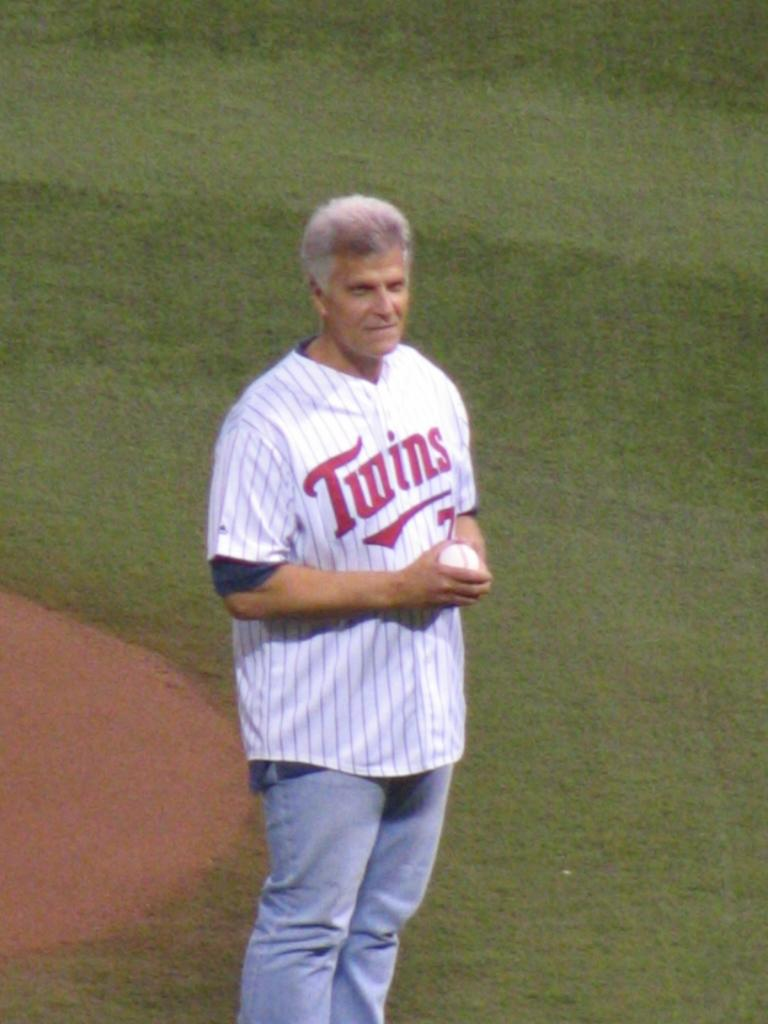Provide a one-sentence caption for the provided image. A man is standing on a baseball field with a Twins jersey on. 